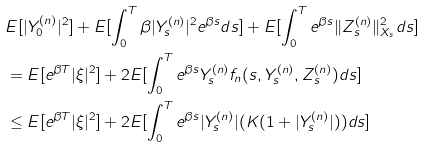<formula> <loc_0><loc_0><loc_500><loc_500>& E [ | Y ^ { ( n ) } _ { 0 } | ^ { 2 } ] + E [ \int _ { 0 } ^ { T } \beta | Y ^ { ( n ) } _ { s } | ^ { 2 } e ^ { \beta s } d s ] + E [ \int _ { 0 } ^ { T } e ^ { \beta s } \| Z ^ { ( n ) } _ { s } \| ^ { 2 } _ { X _ { s } } d s ] \\ & = E [ e ^ { \beta T } | \xi | ^ { 2 } ] + 2 E [ \int _ { 0 } ^ { T } e ^ { \beta s } Y ^ { ( n ) } _ { s } f _ { n } ( s , Y ^ { ( n ) } _ { s } , Z ^ { ( n ) } _ { s } ) d s ] \\ & \leq E [ e ^ { \beta T } | \xi | ^ { 2 } ] + 2 E [ \int _ { 0 } ^ { T } e ^ { \beta s } | Y ^ { ( n ) } _ { s } | ( K ( 1 + | Y _ { s } ^ { ( n ) } | ) ) d s ]</formula> 